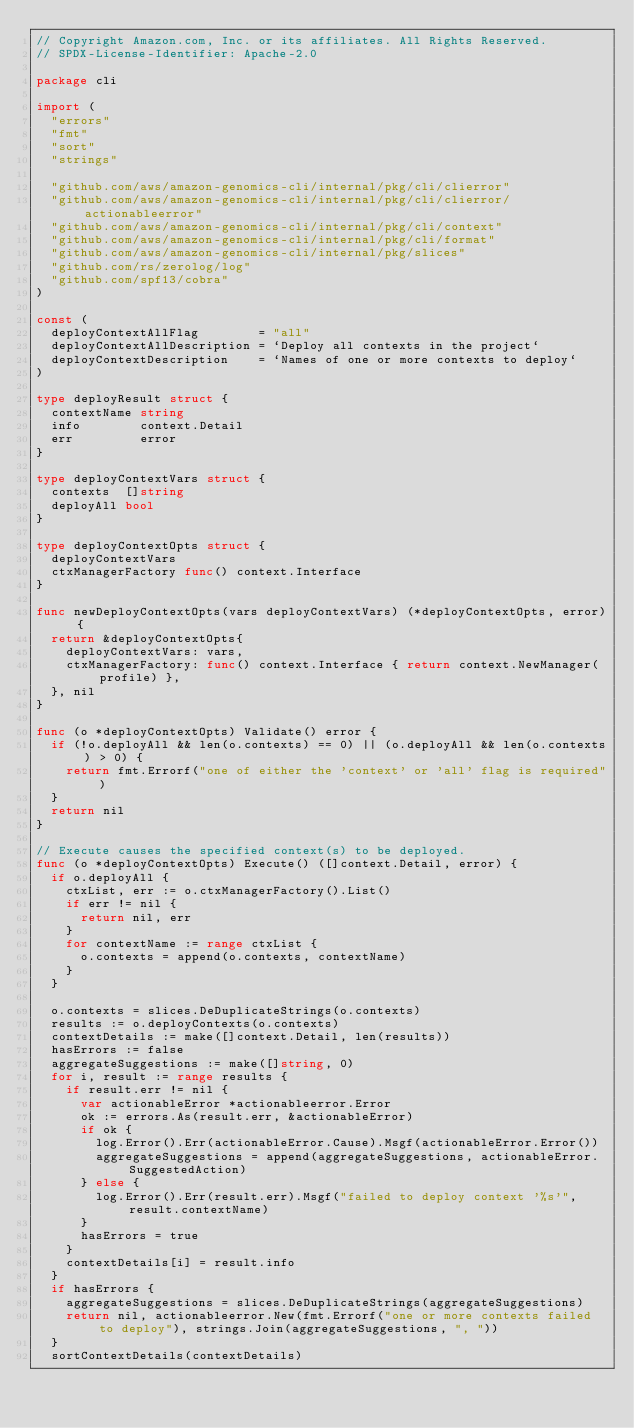<code> <loc_0><loc_0><loc_500><loc_500><_Go_>// Copyright Amazon.com, Inc. or its affiliates. All Rights Reserved.
// SPDX-License-Identifier: Apache-2.0

package cli

import (
	"errors"
	"fmt"
	"sort"
	"strings"

	"github.com/aws/amazon-genomics-cli/internal/pkg/cli/clierror"
	"github.com/aws/amazon-genomics-cli/internal/pkg/cli/clierror/actionableerror"
	"github.com/aws/amazon-genomics-cli/internal/pkg/cli/context"
	"github.com/aws/amazon-genomics-cli/internal/pkg/cli/format"
	"github.com/aws/amazon-genomics-cli/internal/pkg/slices"
	"github.com/rs/zerolog/log"
	"github.com/spf13/cobra"
)

const (
	deployContextAllFlag        = "all"
	deployContextAllDescription = `Deploy all contexts in the project`
	deployContextDescription    = `Names of one or more contexts to deploy`
)

type deployResult struct {
	contextName string
	info        context.Detail
	err         error
}

type deployContextVars struct {
	contexts  []string
	deployAll bool
}

type deployContextOpts struct {
	deployContextVars
	ctxManagerFactory func() context.Interface
}

func newDeployContextOpts(vars deployContextVars) (*deployContextOpts, error) {
	return &deployContextOpts{
		deployContextVars: vars,
		ctxManagerFactory: func() context.Interface { return context.NewManager(profile) },
	}, nil
}

func (o *deployContextOpts) Validate() error {
	if (!o.deployAll && len(o.contexts) == 0) || (o.deployAll && len(o.contexts) > 0) {
		return fmt.Errorf("one of either the 'context' or 'all' flag is required")
	}
	return nil
}

// Execute causes the specified context(s) to be deployed.
func (o *deployContextOpts) Execute() ([]context.Detail, error) {
	if o.deployAll {
		ctxList, err := o.ctxManagerFactory().List()
		if err != nil {
			return nil, err
		}
		for contextName := range ctxList {
			o.contexts = append(o.contexts, contextName)
		}
	}

	o.contexts = slices.DeDuplicateStrings(o.contexts)
	results := o.deployContexts(o.contexts)
	contextDetails := make([]context.Detail, len(results))
	hasErrors := false
	aggregateSuggestions := make([]string, 0)
	for i, result := range results {
		if result.err != nil {
			var actionableError *actionableerror.Error
			ok := errors.As(result.err, &actionableError)
			if ok {
				log.Error().Err(actionableError.Cause).Msgf(actionableError.Error())
				aggregateSuggestions = append(aggregateSuggestions, actionableError.SuggestedAction)
			} else {
				log.Error().Err(result.err).Msgf("failed to deploy context '%s'", result.contextName)
			}
			hasErrors = true
		}
		contextDetails[i] = result.info
	}
	if hasErrors {
		aggregateSuggestions = slices.DeDuplicateStrings(aggregateSuggestions)
		return nil, actionableerror.New(fmt.Errorf("one or more contexts failed to deploy"), strings.Join(aggregateSuggestions, ", "))
	}
	sortContextDetails(contextDetails)</code> 